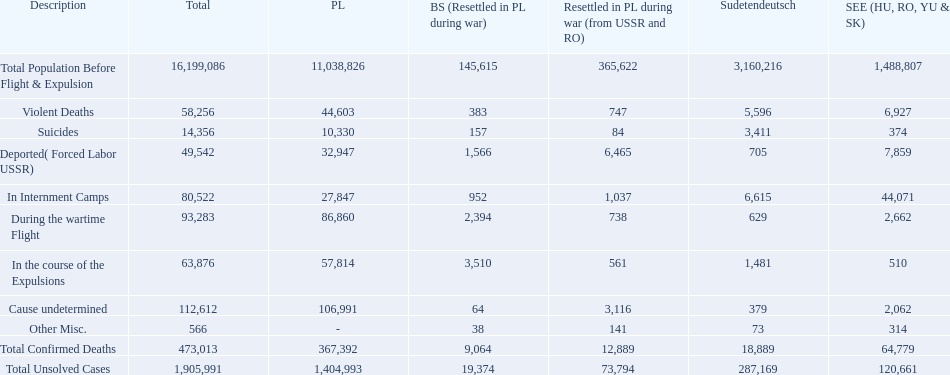What are all of the descriptions? Total Population Before Flight & Expulsion, Violent Deaths, Suicides, Deported( Forced Labor USSR), In Internment Camps, During the wartime Flight, In the course of the Expulsions, Cause undetermined, Other Misc., Total Confirmed Deaths, Total Unsolved Cases. What were their total number of deaths? 16,199,086, 58,256, 14,356, 49,542, 80,522, 93,283, 63,876, 112,612, 566, 473,013, 1,905,991. What about just from violent deaths? 58,256. 